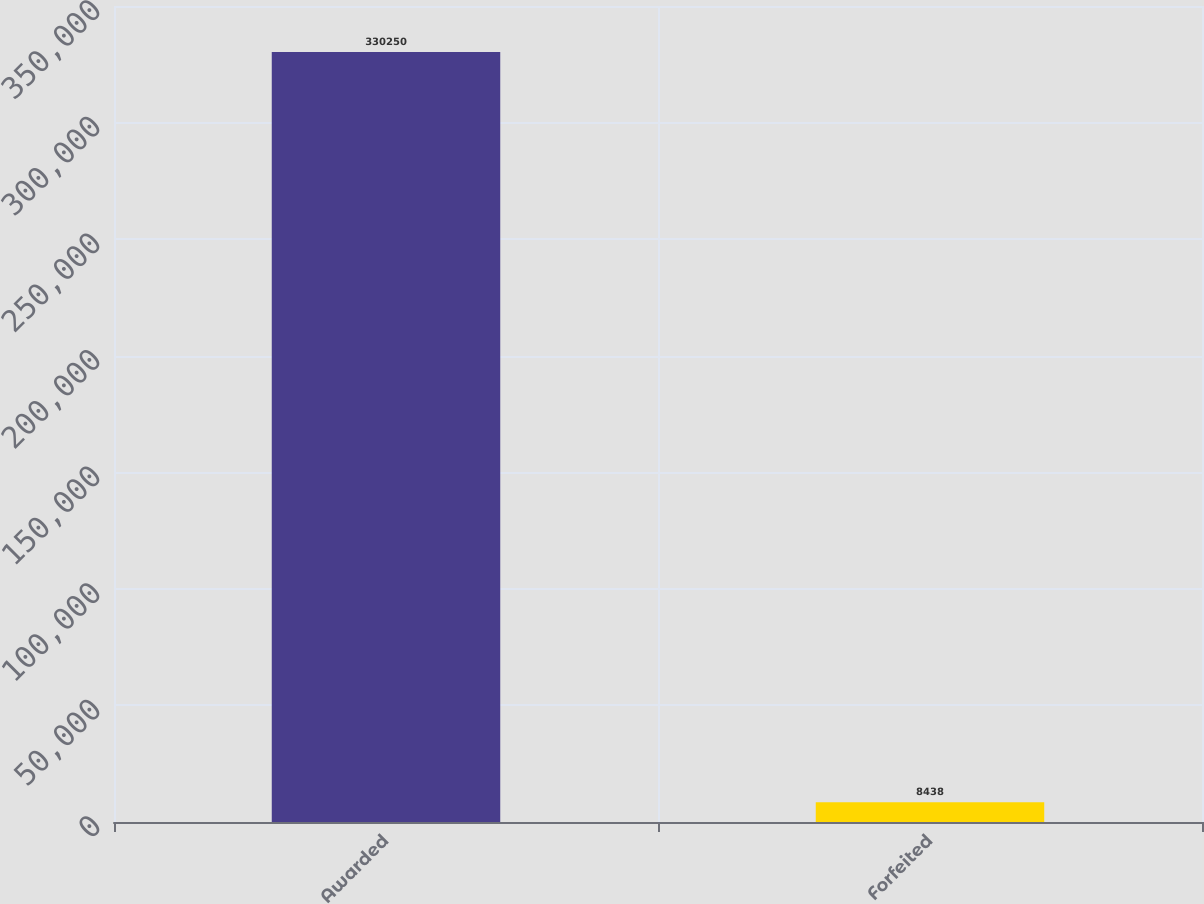Convert chart. <chart><loc_0><loc_0><loc_500><loc_500><bar_chart><fcel>Awarded<fcel>Forfeited<nl><fcel>330250<fcel>8438<nl></chart> 